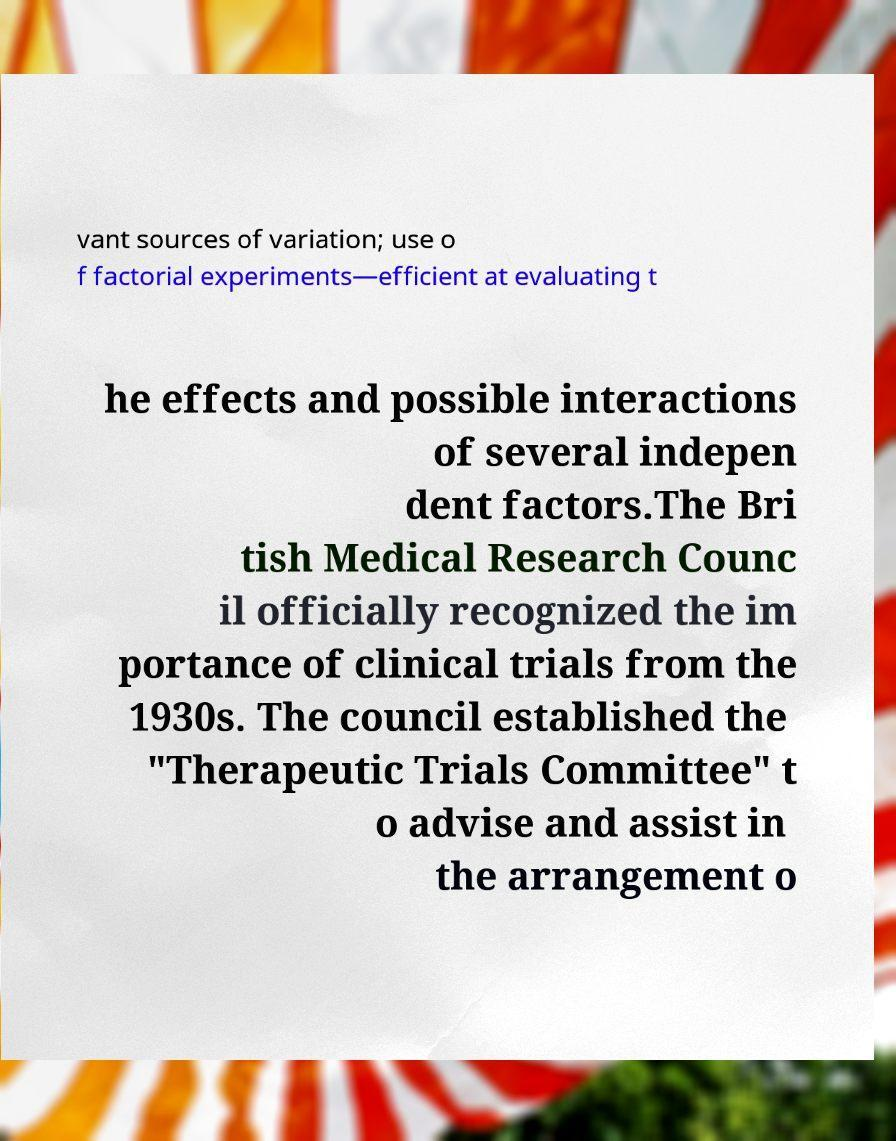Could you extract and type out the text from this image? vant sources of variation; use o f factorial experiments—efficient at evaluating t he effects and possible interactions of several indepen dent factors.The Bri tish Medical Research Counc il officially recognized the im portance of clinical trials from the 1930s. The council established the "Therapeutic Trials Committee" t o advise and assist in the arrangement o 